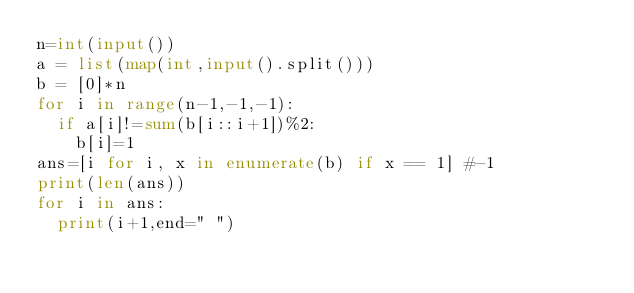<code> <loc_0><loc_0><loc_500><loc_500><_Python_>n=int(input())
a = list(map(int,input().split()))
b = [0]*n
for i in range(n-1,-1,-1):
  if a[i]!=sum(b[i::i+1])%2:
    b[i]=1
ans=[i for i, x in enumerate(b) if x == 1] #-1
print(len(ans))
for i in ans:
  print(i+1,end=" ")</code> 